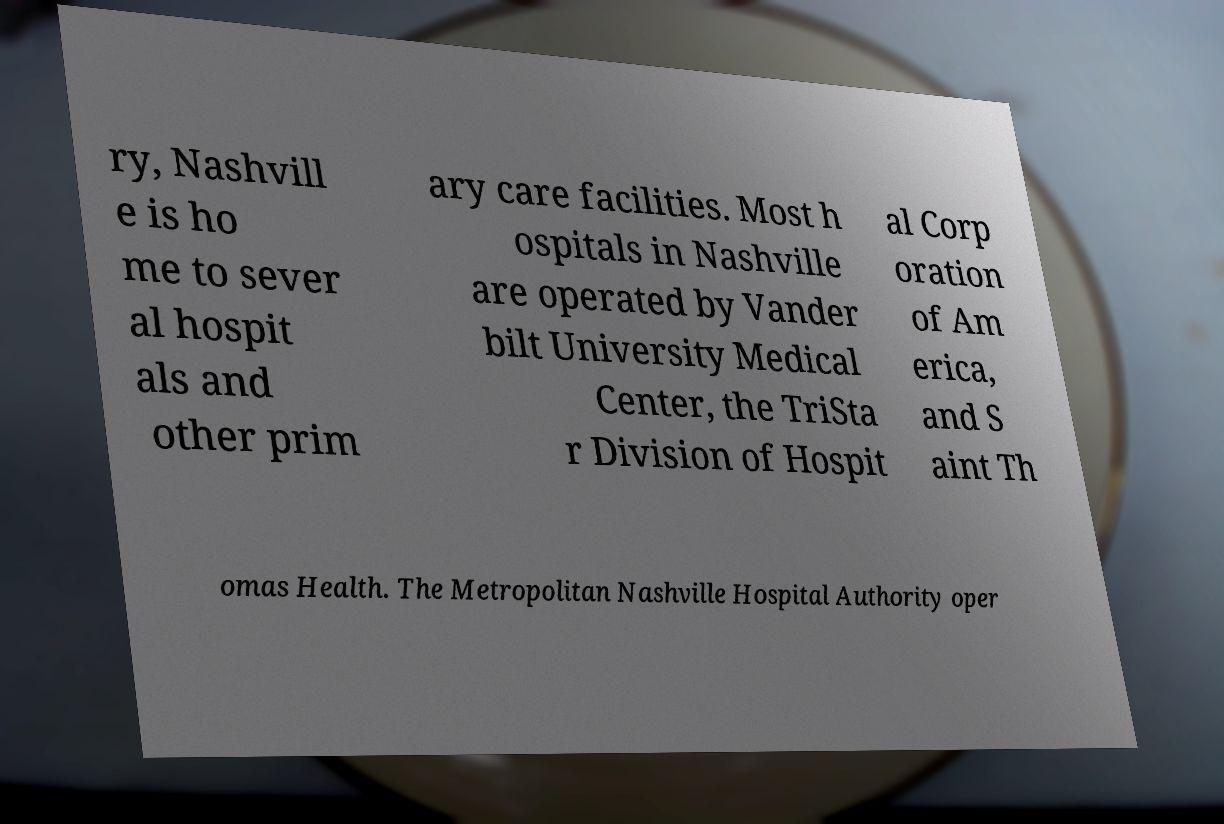What messages or text are displayed in this image? I need them in a readable, typed format. ry, Nashvill e is ho me to sever al hospit als and other prim ary care facilities. Most h ospitals in Nashville are operated by Vander bilt University Medical Center, the TriSta r Division of Hospit al Corp oration of Am erica, and S aint Th omas Health. The Metropolitan Nashville Hospital Authority oper 